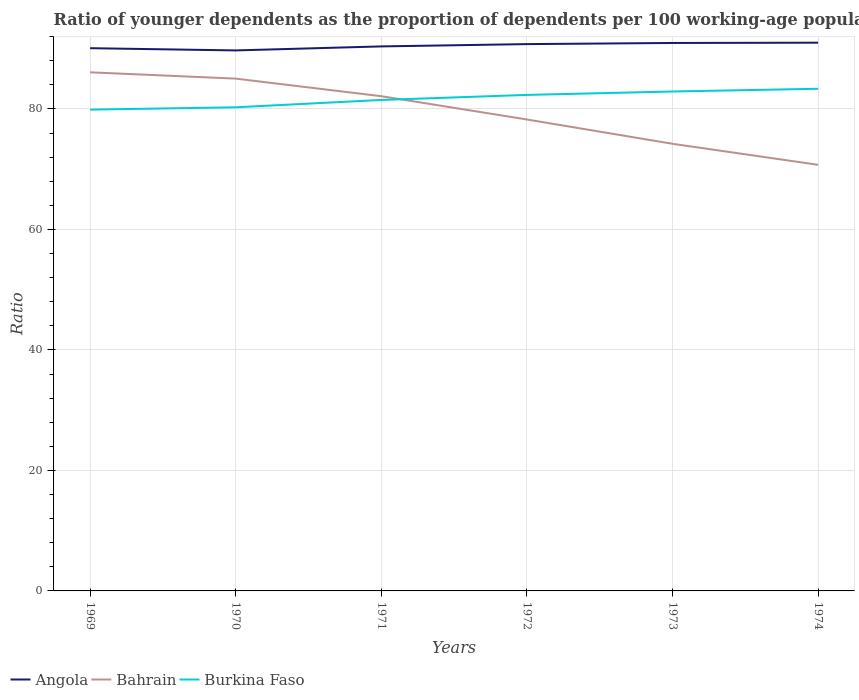How many different coloured lines are there?
Ensure brevity in your answer.  3. Does the line corresponding to Angola intersect with the line corresponding to Burkina Faso?
Offer a very short reply. No. Is the number of lines equal to the number of legend labels?
Your answer should be compact. Yes. Across all years, what is the maximum age dependency ratio(young) in Angola?
Offer a terse response. 89.72. In which year was the age dependency ratio(young) in Angola maximum?
Your answer should be very brief. 1970. What is the total age dependency ratio(young) in Bahrain in the graph?
Make the answer very short. 10.82. What is the difference between the highest and the second highest age dependency ratio(young) in Burkina Faso?
Your answer should be compact. 3.46. What is the difference between the highest and the lowest age dependency ratio(young) in Bahrain?
Keep it short and to the point. 3. How many lines are there?
Keep it short and to the point. 3. How many years are there in the graph?
Offer a terse response. 6. Are the values on the major ticks of Y-axis written in scientific E-notation?
Your response must be concise. No. Does the graph contain grids?
Ensure brevity in your answer.  Yes. How many legend labels are there?
Provide a succinct answer. 3. How are the legend labels stacked?
Your answer should be compact. Horizontal. What is the title of the graph?
Keep it short and to the point. Ratio of younger dependents as the proportion of dependents per 100 working-age population. Does "Japan" appear as one of the legend labels in the graph?
Keep it short and to the point. No. What is the label or title of the X-axis?
Provide a short and direct response. Years. What is the label or title of the Y-axis?
Provide a short and direct response. Ratio. What is the Ratio in Angola in 1969?
Your answer should be very brief. 90.09. What is the Ratio in Bahrain in 1969?
Your answer should be very brief. 86.09. What is the Ratio of Burkina Faso in 1969?
Give a very brief answer. 79.89. What is the Ratio in Angola in 1970?
Your response must be concise. 89.72. What is the Ratio of Bahrain in 1970?
Offer a very short reply. 85.04. What is the Ratio in Burkina Faso in 1970?
Offer a terse response. 80.28. What is the Ratio in Angola in 1971?
Make the answer very short. 90.39. What is the Ratio of Bahrain in 1971?
Your answer should be very brief. 82.12. What is the Ratio in Burkina Faso in 1971?
Give a very brief answer. 81.5. What is the Ratio of Angola in 1972?
Your response must be concise. 90.77. What is the Ratio in Bahrain in 1972?
Offer a terse response. 78.26. What is the Ratio in Burkina Faso in 1972?
Provide a short and direct response. 82.34. What is the Ratio of Angola in 1973?
Your answer should be compact. 90.96. What is the Ratio in Bahrain in 1973?
Keep it short and to the point. 74.22. What is the Ratio of Burkina Faso in 1973?
Provide a short and direct response. 82.9. What is the Ratio of Angola in 1974?
Provide a succinct answer. 91.01. What is the Ratio of Bahrain in 1974?
Offer a terse response. 70.73. What is the Ratio of Burkina Faso in 1974?
Your answer should be very brief. 83.35. Across all years, what is the maximum Ratio of Angola?
Provide a short and direct response. 91.01. Across all years, what is the maximum Ratio in Bahrain?
Give a very brief answer. 86.09. Across all years, what is the maximum Ratio of Burkina Faso?
Provide a short and direct response. 83.35. Across all years, what is the minimum Ratio in Angola?
Give a very brief answer. 89.72. Across all years, what is the minimum Ratio in Bahrain?
Provide a short and direct response. 70.73. Across all years, what is the minimum Ratio in Burkina Faso?
Ensure brevity in your answer.  79.89. What is the total Ratio of Angola in the graph?
Provide a short and direct response. 542.93. What is the total Ratio in Bahrain in the graph?
Make the answer very short. 476.46. What is the total Ratio in Burkina Faso in the graph?
Your answer should be compact. 490.26. What is the difference between the Ratio of Angola in 1969 and that in 1970?
Keep it short and to the point. 0.37. What is the difference between the Ratio of Bahrain in 1969 and that in 1970?
Your answer should be very brief. 1.05. What is the difference between the Ratio of Burkina Faso in 1969 and that in 1970?
Your answer should be very brief. -0.39. What is the difference between the Ratio of Angola in 1969 and that in 1971?
Give a very brief answer. -0.3. What is the difference between the Ratio in Bahrain in 1969 and that in 1971?
Keep it short and to the point. 3.97. What is the difference between the Ratio in Burkina Faso in 1969 and that in 1971?
Keep it short and to the point. -1.61. What is the difference between the Ratio in Angola in 1969 and that in 1972?
Offer a very short reply. -0.68. What is the difference between the Ratio in Bahrain in 1969 and that in 1972?
Your answer should be compact. 7.83. What is the difference between the Ratio in Burkina Faso in 1969 and that in 1972?
Your response must be concise. -2.44. What is the difference between the Ratio in Angola in 1969 and that in 1973?
Give a very brief answer. -0.86. What is the difference between the Ratio of Bahrain in 1969 and that in 1973?
Make the answer very short. 11.86. What is the difference between the Ratio in Burkina Faso in 1969 and that in 1973?
Give a very brief answer. -3.01. What is the difference between the Ratio in Angola in 1969 and that in 1974?
Provide a short and direct response. -0.91. What is the difference between the Ratio of Bahrain in 1969 and that in 1974?
Give a very brief answer. 15.36. What is the difference between the Ratio of Burkina Faso in 1969 and that in 1974?
Ensure brevity in your answer.  -3.46. What is the difference between the Ratio in Angola in 1970 and that in 1971?
Ensure brevity in your answer.  -0.67. What is the difference between the Ratio in Bahrain in 1970 and that in 1971?
Keep it short and to the point. 2.92. What is the difference between the Ratio in Burkina Faso in 1970 and that in 1971?
Offer a very short reply. -1.22. What is the difference between the Ratio of Angola in 1970 and that in 1972?
Your response must be concise. -1.05. What is the difference between the Ratio of Bahrain in 1970 and that in 1972?
Offer a terse response. 6.78. What is the difference between the Ratio of Burkina Faso in 1970 and that in 1972?
Offer a very short reply. -2.06. What is the difference between the Ratio in Angola in 1970 and that in 1973?
Your response must be concise. -1.24. What is the difference between the Ratio of Bahrain in 1970 and that in 1973?
Provide a short and direct response. 10.82. What is the difference between the Ratio in Burkina Faso in 1970 and that in 1973?
Provide a succinct answer. -2.62. What is the difference between the Ratio of Angola in 1970 and that in 1974?
Offer a very short reply. -1.29. What is the difference between the Ratio of Bahrain in 1970 and that in 1974?
Your response must be concise. 14.31. What is the difference between the Ratio of Burkina Faso in 1970 and that in 1974?
Your answer should be compact. -3.08. What is the difference between the Ratio in Angola in 1971 and that in 1972?
Keep it short and to the point. -0.38. What is the difference between the Ratio in Bahrain in 1971 and that in 1972?
Your answer should be very brief. 3.86. What is the difference between the Ratio in Burkina Faso in 1971 and that in 1972?
Your answer should be very brief. -0.84. What is the difference between the Ratio of Angola in 1971 and that in 1973?
Give a very brief answer. -0.57. What is the difference between the Ratio of Bahrain in 1971 and that in 1973?
Give a very brief answer. 7.9. What is the difference between the Ratio of Burkina Faso in 1971 and that in 1973?
Provide a short and direct response. -1.4. What is the difference between the Ratio of Angola in 1971 and that in 1974?
Give a very brief answer. -0.62. What is the difference between the Ratio in Bahrain in 1971 and that in 1974?
Keep it short and to the point. 11.39. What is the difference between the Ratio in Burkina Faso in 1971 and that in 1974?
Ensure brevity in your answer.  -1.86. What is the difference between the Ratio in Angola in 1972 and that in 1973?
Give a very brief answer. -0.19. What is the difference between the Ratio of Bahrain in 1972 and that in 1973?
Your answer should be very brief. 4.03. What is the difference between the Ratio of Burkina Faso in 1972 and that in 1973?
Your answer should be compact. -0.57. What is the difference between the Ratio of Angola in 1972 and that in 1974?
Provide a short and direct response. -0.24. What is the difference between the Ratio in Bahrain in 1972 and that in 1974?
Ensure brevity in your answer.  7.52. What is the difference between the Ratio in Burkina Faso in 1972 and that in 1974?
Provide a short and direct response. -1.02. What is the difference between the Ratio in Angola in 1973 and that in 1974?
Your response must be concise. -0.05. What is the difference between the Ratio in Bahrain in 1973 and that in 1974?
Make the answer very short. 3.49. What is the difference between the Ratio of Burkina Faso in 1973 and that in 1974?
Your answer should be very brief. -0.45. What is the difference between the Ratio in Angola in 1969 and the Ratio in Bahrain in 1970?
Provide a succinct answer. 5.05. What is the difference between the Ratio in Angola in 1969 and the Ratio in Burkina Faso in 1970?
Ensure brevity in your answer.  9.81. What is the difference between the Ratio in Bahrain in 1969 and the Ratio in Burkina Faso in 1970?
Keep it short and to the point. 5.81. What is the difference between the Ratio in Angola in 1969 and the Ratio in Bahrain in 1971?
Ensure brevity in your answer.  7.97. What is the difference between the Ratio of Angola in 1969 and the Ratio of Burkina Faso in 1971?
Ensure brevity in your answer.  8.59. What is the difference between the Ratio in Bahrain in 1969 and the Ratio in Burkina Faso in 1971?
Provide a succinct answer. 4.59. What is the difference between the Ratio of Angola in 1969 and the Ratio of Bahrain in 1972?
Your response must be concise. 11.84. What is the difference between the Ratio of Angola in 1969 and the Ratio of Burkina Faso in 1972?
Your answer should be very brief. 7.76. What is the difference between the Ratio in Bahrain in 1969 and the Ratio in Burkina Faso in 1972?
Provide a short and direct response. 3.75. What is the difference between the Ratio in Angola in 1969 and the Ratio in Bahrain in 1973?
Your answer should be very brief. 15.87. What is the difference between the Ratio of Angola in 1969 and the Ratio of Burkina Faso in 1973?
Provide a short and direct response. 7.19. What is the difference between the Ratio in Bahrain in 1969 and the Ratio in Burkina Faso in 1973?
Give a very brief answer. 3.19. What is the difference between the Ratio of Angola in 1969 and the Ratio of Bahrain in 1974?
Your response must be concise. 19.36. What is the difference between the Ratio of Angola in 1969 and the Ratio of Burkina Faso in 1974?
Ensure brevity in your answer.  6.74. What is the difference between the Ratio in Bahrain in 1969 and the Ratio in Burkina Faso in 1974?
Ensure brevity in your answer.  2.73. What is the difference between the Ratio in Angola in 1970 and the Ratio in Bahrain in 1971?
Offer a very short reply. 7.6. What is the difference between the Ratio of Angola in 1970 and the Ratio of Burkina Faso in 1971?
Offer a very short reply. 8.22. What is the difference between the Ratio of Bahrain in 1970 and the Ratio of Burkina Faso in 1971?
Provide a succinct answer. 3.54. What is the difference between the Ratio in Angola in 1970 and the Ratio in Bahrain in 1972?
Provide a short and direct response. 11.46. What is the difference between the Ratio of Angola in 1970 and the Ratio of Burkina Faso in 1972?
Your answer should be very brief. 7.38. What is the difference between the Ratio in Bahrain in 1970 and the Ratio in Burkina Faso in 1972?
Give a very brief answer. 2.7. What is the difference between the Ratio in Angola in 1970 and the Ratio in Bahrain in 1973?
Ensure brevity in your answer.  15.5. What is the difference between the Ratio of Angola in 1970 and the Ratio of Burkina Faso in 1973?
Offer a very short reply. 6.82. What is the difference between the Ratio of Bahrain in 1970 and the Ratio of Burkina Faso in 1973?
Provide a succinct answer. 2.14. What is the difference between the Ratio of Angola in 1970 and the Ratio of Bahrain in 1974?
Your response must be concise. 18.99. What is the difference between the Ratio of Angola in 1970 and the Ratio of Burkina Faso in 1974?
Your answer should be compact. 6.37. What is the difference between the Ratio of Bahrain in 1970 and the Ratio of Burkina Faso in 1974?
Your answer should be very brief. 1.68. What is the difference between the Ratio of Angola in 1971 and the Ratio of Bahrain in 1972?
Your answer should be very brief. 12.13. What is the difference between the Ratio in Angola in 1971 and the Ratio in Burkina Faso in 1972?
Provide a succinct answer. 8.05. What is the difference between the Ratio in Bahrain in 1971 and the Ratio in Burkina Faso in 1972?
Provide a short and direct response. -0.22. What is the difference between the Ratio of Angola in 1971 and the Ratio of Bahrain in 1973?
Your answer should be very brief. 16.16. What is the difference between the Ratio of Angola in 1971 and the Ratio of Burkina Faso in 1973?
Your answer should be compact. 7.49. What is the difference between the Ratio of Bahrain in 1971 and the Ratio of Burkina Faso in 1973?
Offer a very short reply. -0.78. What is the difference between the Ratio of Angola in 1971 and the Ratio of Bahrain in 1974?
Your response must be concise. 19.66. What is the difference between the Ratio of Angola in 1971 and the Ratio of Burkina Faso in 1974?
Make the answer very short. 7.03. What is the difference between the Ratio in Bahrain in 1971 and the Ratio in Burkina Faso in 1974?
Offer a terse response. -1.23. What is the difference between the Ratio in Angola in 1972 and the Ratio in Bahrain in 1973?
Your answer should be compact. 16.54. What is the difference between the Ratio of Angola in 1972 and the Ratio of Burkina Faso in 1973?
Your response must be concise. 7.87. What is the difference between the Ratio of Bahrain in 1972 and the Ratio of Burkina Faso in 1973?
Keep it short and to the point. -4.64. What is the difference between the Ratio of Angola in 1972 and the Ratio of Bahrain in 1974?
Ensure brevity in your answer.  20.04. What is the difference between the Ratio of Angola in 1972 and the Ratio of Burkina Faso in 1974?
Provide a short and direct response. 7.41. What is the difference between the Ratio of Bahrain in 1972 and the Ratio of Burkina Faso in 1974?
Keep it short and to the point. -5.1. What is the difference between the Ratio of Angola in 1973 and the Ratio of Bahrain in 1974?
Offer a terse response. 20.23. What is the difference between the Ratio in Angola in 1973 and the Ratio in Burkina Faso in 1974?
Keep it short and to the point. 7.6. What is the difference between the Ratio of Bahrain in 1973 and the Ratio of Burkina Faso in 1974?
Offer a terse response. -9.13. What is the average Ratio in Angola per year?
Ensure brevity in your answer.  90.49. What is the average Ratio in Bahrain per year?
Offer a terse response. 79.41. What is the average Ratio in Burkina Faso per year?
Offer a terse response. 81.71. In the year 1969, what is the difference between the Ratio of Angola and Ratio of Bahrain?
Provide a short and direct response. 4. In the year 1969, what is the difference between the Ratio in Bahrain and Ratio in Burkina Faso?
Ensure brevity in your answer.  6.2. In the year 1970, what is the difference between the Ratio of Angola and Ratio of Bahrain?
Ensure brevity in your answer.  4.68. In the year 1970, what is the difference between the Ratio of Angola and Ratio of Burkina Faso?
Keep it short and to the point. 9.44. In the year 1970, what is the difference between the Ratio of Bahrain and Ratio of Burkina Faso?
Provide a succinct answer. 4.76. In the year 1971, what is the difference between the Ratio in Angola and Ratio in Bahrain?
Your answer should be very brief. 8.27. In the year 1971, what is the difference between the Ratio of Angola and Ratio of Burkina Faso?
Offer a very short reply. 8.89. In the year 1971, what is the difference between the Ratio of Bahrain and Ratio of Burkina Faso?
Offer a terse response. 0.62. In the year 1972, what is the difference between the Ratio of Angola and Ratio of Bahrain?
Your response must be concise. 12.51. In the year 1972, what is the difference between the Ratio of Angola and Ratio of Burkina Faso?
Your answer should be compact. 8.43. In the year 1972, what is the difference between the Ratio in Bahrain and Ratio in Burkina Faso?
Offer a very short reply. -4.08. In the year 1973, what is the difference between the Ratio of Angola and Ratio of Bahrain?
Offer a very short reply. 16.73. In the year 1973, what is the difference between the Ratio in Angola and Ratio in Burkina Faso?
Keep it short and to the point. 8.05. In the year 1973, what is the difference between the Ratio in Bahrain and Ratio in Burkina Faso?
Your answer should be very brief. -8.68. In the year 1974, what is the difference between the Ratio in Angola and Ratio in Bahrain?
Make the answer very short. 20.27. In the year 1974, what is the difference between the Ratio of Angola and Ratio of Burkina Faso?
Offer a very short reply. 7.65. In the year 1974, what is the difference between the Ratio in Bahrain and Ratio in Burkina Faso?
Your answer should be very brief. -12.62. What is the ratio of the Ratio of Bahrain in 1969 to that in 1970?
Your answer should be compact. 1.01. What is the ratio of the Ratio of Angola in 1969 to that in 1971?
Offer a very short reply. 1. What is the ratio of the Ratio in Bahrain in 1969 to that in 1971?
Your response must be concise. 1.05. What is the ratio of the Ratio in Burkina Faso in 1969 to that in 1971?
Offer a terse response. 0.98. What is the ratio of the Ratio of Angola in 1969 to that in 1972?
Provide a succinct answer. 0.99. What is the ratio of the Ratio of Bahrain in 1969 to that in 1972?
Ensure brevity in your answer.  1.1. What is the ratio of the Ratio of Burkina Faso in 1969 to that in 1972?
Make the answer very short. 0.97. What is the ratio of the Ratio of Bahrain in 1969 to that in 1973?
Provide a short and direct response. 1.16. What is the ratio of the Ratio in Burkina Faso in 1969 to that in 1973?
Provide a succinct answer. 0.96. What is the ratio of the Ratio of Angola in 1969 to that in 1974?
Your answer should be compact. 0.99. What is the ratio of the Ratio of Bahrain in 1969 to that in 1974?
Give a very brief answer. 1.22. What is the ratio of the Ratio of Burkina Faso in 1969 to that in 1974?
Offer a very short reply. 0.96. What is the ratio of the Ratio of Angola in 1970 to that in 1971?
Offer a very short reply. 0.99. What is the ratio of the Ratio in Bahrain in 1970 to that in 1971?
Make the answer very short. 1.04. What is the ratio of the Ratio of Bahrain in 1970 to that in 1972?
Give a very brief answer. 1.09. What is the ratio of the Ratio of Burkina Faso in 1970 to that in 1972?
Your response must be concise. 0.97. What is the ratio of the Ratio of Angola in 1970 to that in 1973?
Provide a succinct answer. 0.99. What is the ratio of the Ratio in Bahrain in 1970 to that in 1973?
Make the answer very short. 1.15. What is the ratio of the Ratio of Burkina Faso in 1970 to that in 1973?
Provide a succinct answer. 0.97. What is the ratio of the Ratio in Angola in 1970 to that in 1974?
Offer a terse response. 0.99. What is the ratio of the Ratio of Bahrain in 1970 to that in 1974?
Offer a terse response. 1.2. What is the ratio of the Ratio in Burkina Faso in 1970 to that in 1974?
Keep it short and to the point. 0.96. What is the ratio of the Ratio of Angola in 1971 to that in 1972?
Make the answer very short. 1. What is the ratio of the Ratio of Bahrain in 1971 to that in 1972?
Your answer should be compact. 1.05. What is the ratio of the Ratio of Bahrain in 1971 to that in 1973?
Make the answer very short. 1.11. What is the ratio of the Ratio of Burkina Faso in 1971 to that in 1973?
Keep it short and to the point. 0.98. What is the ratio of the Ratio in Angola in 1971 to that in 1974?
Give a very brief answer. 0.99. What is the ratio of the Ratio in Bahrain in 1971 to that in 1974?
Your answer should be compact. 1.16. What is the ratio of the Ratio of Burkina Faso in 1971 to that in 1974?
Ensure brevity in your answer.  0.98. What is the ratio of the Ratio in Angola in 1972 to that in 1973?
Provide a short and direct response. 1. What is the ratio of the Ratio of Bahrain in 1972 to that in 1973?
Offer a terse response. 1.05. What is the ratio of the Ratio in Bahrain in 1972 to that in 1974?
Your answer should be compact. 1.11. What is the ratio of the Ratio of Angola in 1973 to that in 1974?
Ensure brevity in your answer.  1. What is the ratio of the Ratio of Bahrain in 1973 to that in 1974?
Offer a terse response. 1.05. What is the ratio of the Ratio in Burkina Faso in 1973 to that in 1974?
Make the answer very short. 0.99. What is the difference between the highest and the second highest Ratio in Angola?
Your answer should be very brief. 0.05. What is the difference between the highest and the second highest Ratio of Bahrain?
Give a very brief answer. 1.05. What is the difference between the highest and the second highest Ratio of Burkina Faso?
Offer a terse response. 0.45. What is the difference between the highest and the lowest Ratio of Angola?
Offer a very short reply. 1.29. What is the difference between the highest and the lowest Ratio of Bahrain?
Give a very brief answer. 15.36. What is the difference between the highest and the lowest Ratio of Burkina Faso?
Offer a very short reply. 3.46. 